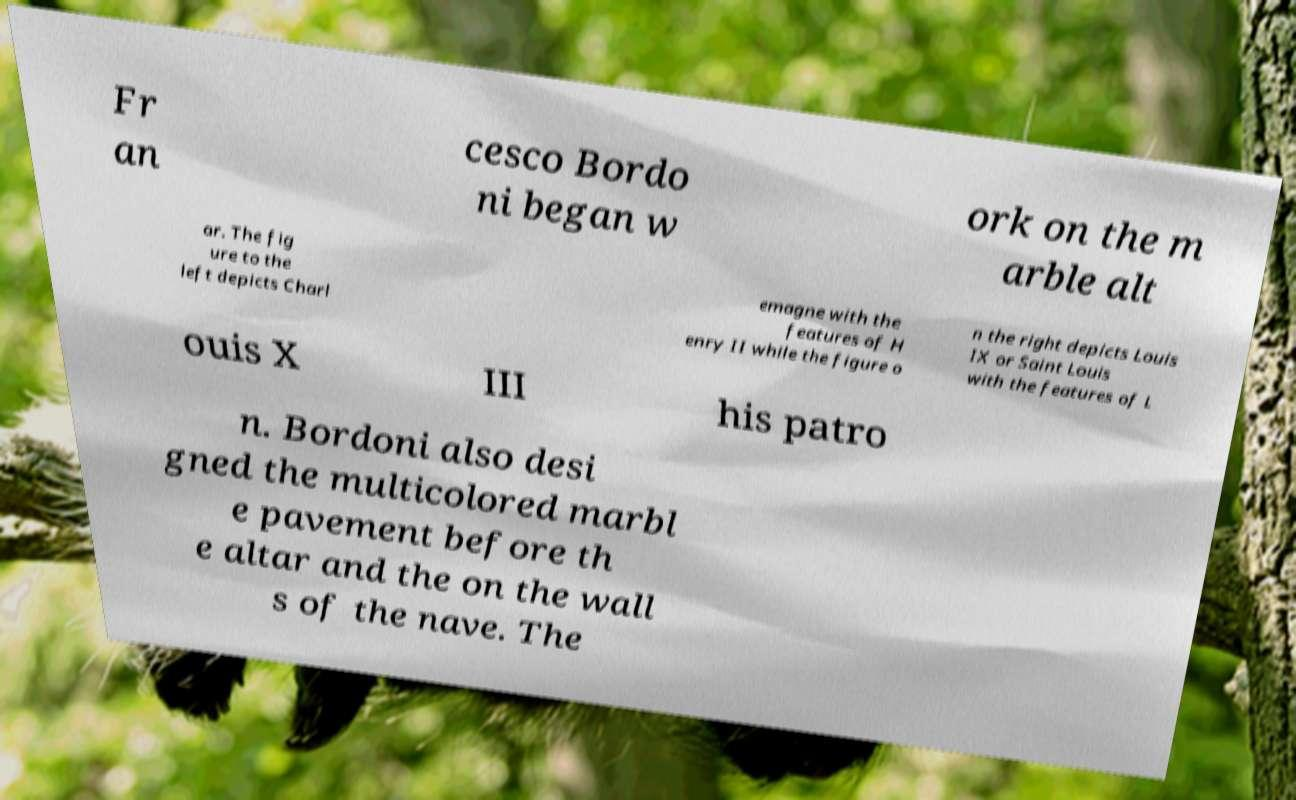For documentation purposes, I need the text within this image transcribed. Could you provide that? Fr an cesco Bordo ni began w ork on the m arble alt ar. The fig ure to the left depicts Charl emagne with the features of H enry II while the figure o n the right depicts Louis IX or Saint Louis with the features of L ouis X III his patro n. Bordoni also desi gned the multicolored marbl e pavement before th e altar and the on the wall s of the nave. The 